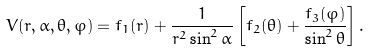Convert formula to latex. <formula><loc_0><loc_0><loc_500><loc_500>V ( r , \alpha , \theta , \varphi ) = f _ { 1 } ( r ) + \frac { 1 } { r ^ { 2 } \sin ^ { 2 } \alpha } \left [ f _ { 2 } ( \theta ) + \frac { f _ { 3 } ( \varphi ) } { \sin ^ { 2 } \theta } \right ] .</formula> 